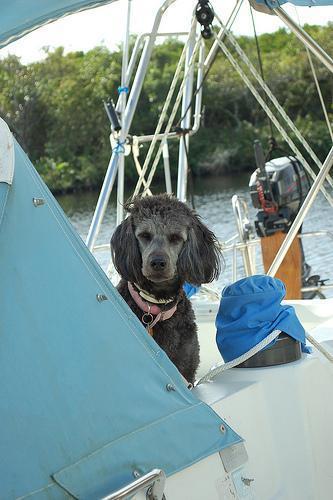How many dogs are there?
Give a very brief answer. 1. 